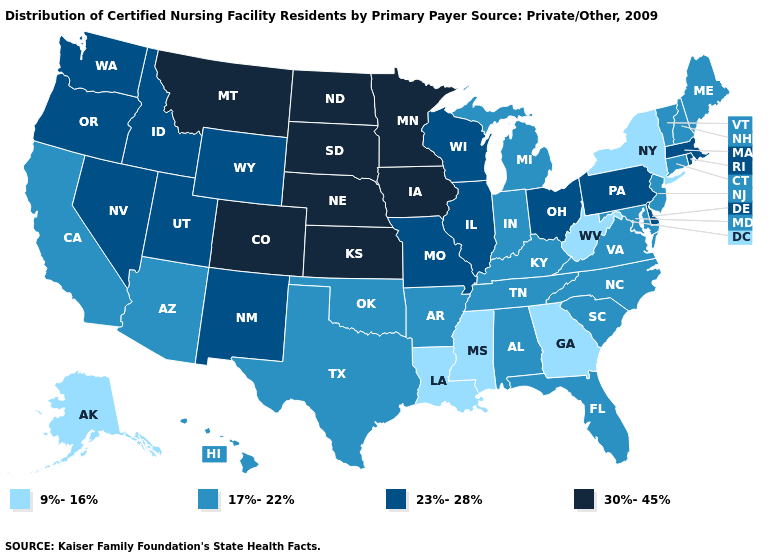Which states have the highest value in the USA?
Short answer required. Colorado, Iowa, Kansas, Minnesota, Montana, Nebraska, North Dakota, South Dakota. What is the value of California?
Answer briefly. 17%-22%. What is the value of Rhode Island?
Short answer required. 23%-28%. What is the value of Washington?
Concise answer only. 23%-28%. Does the map have missing data?
Quick response, please. No. What is the lowest value in the USA?
Quick response, please. 9%-16%. What is the lowest value in the USA?
Quick response, please. 9%-16%. Does the first symbol in the legend represent the smallest category?
Keep it brief. Yes. What is the value of Alaska?
Give a very brief answer. 9%-16%. Name the states that have a value in the range 17%-22%?
Give a very brief answer. Alabama, Arizona, Arkansas, California, Connecticut, Florida, Hawaii, Indiana, Kentucky, Maine, Maryland, Michigan, New Hampshire, New Jersey, North Carolina, Oklahoma, South Carolina, Tennessee, Texas, Vermont, Virginia. Does Connecticut have the lowest value in the USA?
Write a very short answer. No. Name the states that have a value in the range 30%-45%?
Quick response, please. Colorado, Iowa, Kansas, Minnesota, Montana, Nebraska, North Dakota, South Dakota. Is the legend a continuous bar?
Answer briefly. No. Among the states that border Texas , which have the highest value?
Keep it brief. New Mexico. 